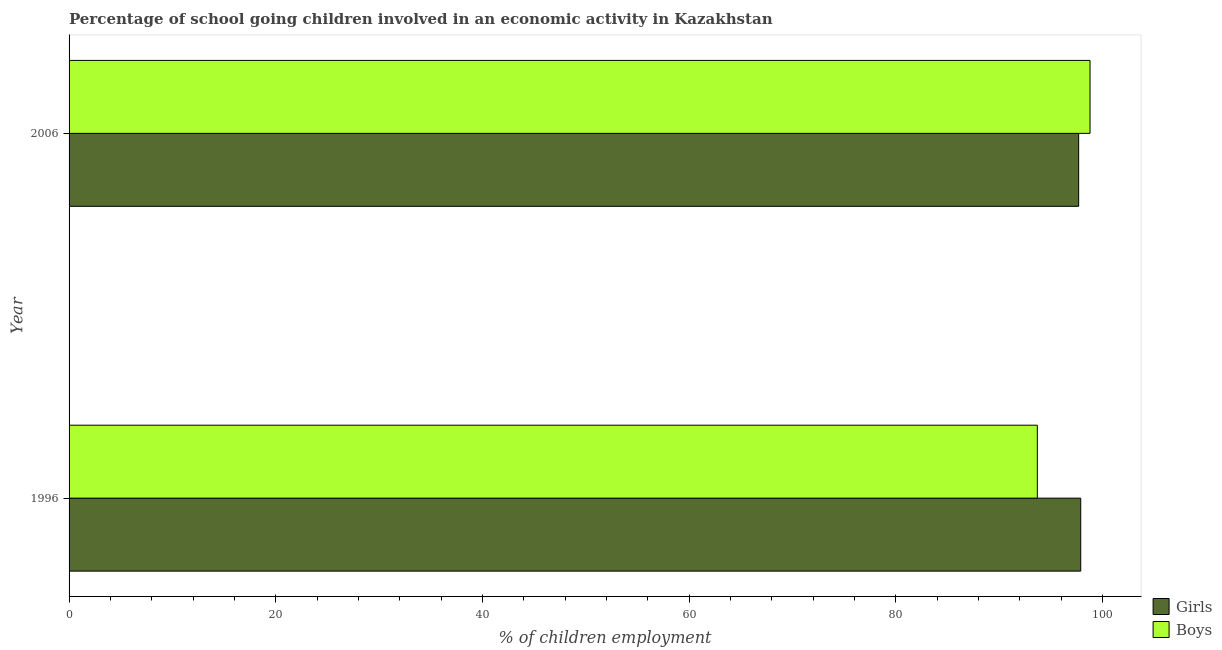Are the number of bars on each tick of the Y-axis equal?
Keep it short and to the point. Yes. How many bars are there on the 1st tick from the top?
Your answer should be compact. 2. How many bars are there on the 2nd tick from the bottom?
Keep it short and to the point. 2. What is the label of the 2nd group of bars from the top?
Ensure brevity in your answer.  1996. What is the percentage of school going girls in 2006?
Make the answer very short. 97.7. Across all years, what is the maximum percentage of school going girls?
Make the answer very short. 97.9. Across all years, what is the minimum percentage of school going boys?
Provide a short and direct response. 93.7. In which year was the percentage of school going girls maximum?
Your response must be concise. 1996. What is the total percentage of school going girls in the graph?
Keep it short and to the point. 195.6. What is the difference between the percentage of school going boys in 1996 and that in 2006?
Your answer should be compact. -5.1. What is the average percentage of school going boys per year?
Make the answer very short. 96.25. In the year 2006, what is the difference between the percentage of school going girls and percentage of school going boys?
Your answer should be very brief. -1.1. What does the 2nd bar from the top in 1996 represents?
Ensure brevity in your answer.  Girls. What does the 2nd bar from the bottom in 1996 represents?
Ensure brevity in your answer.  Boys. How many bars are there?
Provide a succinct answer. 4. Are all the bars in the graph horizontal?
Your answer should be very brief. Yes. What is the difference between two consecutive major ticks on the X-axis?
Your response must be concise. 20. Does the graph contain any zero values?
Offer a terse response. No. Does the graph contain grids?
Offer a terse response. No. How many legend labels are there?
Offer a terse response. 2. What is the title of the graph?
Offer a terse response. Percentage of school going children involved in an economic activity in Kazakhstan. Does "Food and tobacco" appear as one of the legend labels in the graph?
Ensure brevity in your answer.  No. What is the label or title of the X-axis?
Keep it short and to the point. % of children employment. What is the label or title of the Y-axis?
Your answer should be very brief. Year. What is the % of children employment in Girls in 1996?
Keep it short and to the point. 97.9. What is the % of children employment of Boys in 1996?
Your answer should be compact. 93.7. What is the % of children employment of Girls in 2006?
Provide a short and direct response. 97.7. What is the % of children employment in Boys in 2006?
Offer a very short reply. 98.8. Across all years, what is the maximum % of children employment in Girls?
Provide a short and direct response. 97.9. Across all years, what is the maximum % of children employment of Boys?
Keep it short and to the point. 98.8. Across all years, what is the minimum % of children employment in Girls?
Offer a very short reply. 97.7. Across all years, what is the minimum % of children employment in Boys?
Provide a short and direct response. 93.7. What is the total % of children employment of Girls in the graph?
Your answer should be compact. 195.6. What is the total % of children employment of Boys in the graph?
Your answer should be compact. 192.5. What is the difference between the % of children employment of Girls in 1996 and the % of children employment of Boys in 2006?
Your answer should be very brief. -0.9. What is the average % of children employment in Girls per year?
Offer a terse response. 97.8. What is the average % of children employment of Boys per year?
Make the answer very short. 96.25. In the year 1996, what is the difference between the % of children employment in Girls and % of children employment in Boys?
Keep it short and to the point. 4.2. What is the ratio of the % of children employment of Girls in 1996 to that in 2006?
Your answer should be compact. 1. What is the ratio of the % of children employment of Boys in 1996 to that in 2006?
Provide a short and direct response. 0.95. What is the difference between the highest and the second highest % of children employment in Girls?
Make the answer very short. 0.2. 